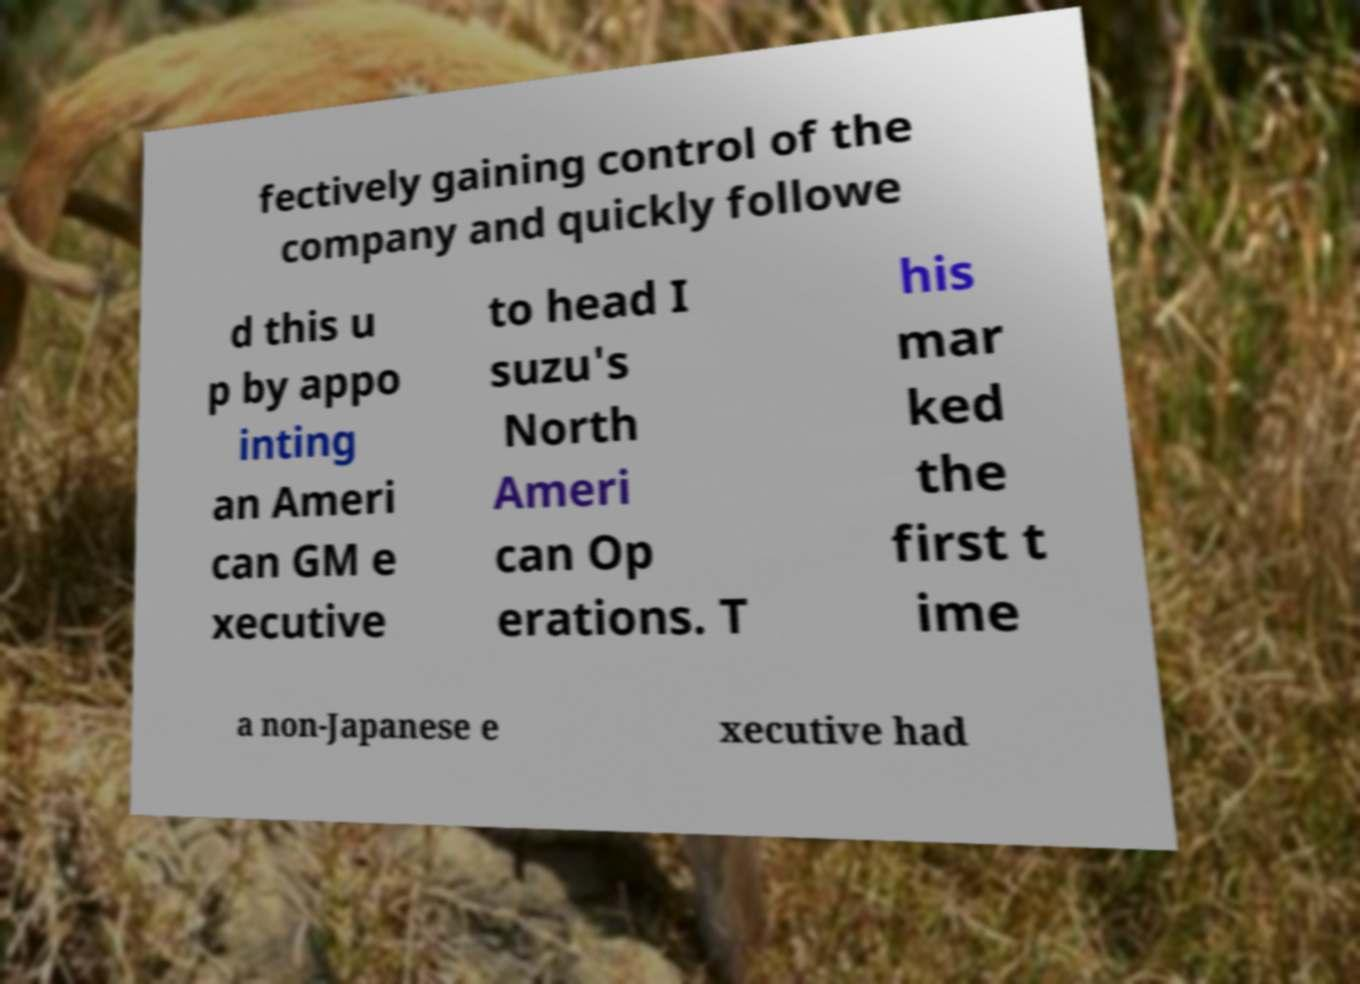Can you read and provide the text displayed in the image?This photo seems to have some interesting text. Can you extract and type it out for me? fectively gaining control of the company and quickly followe d this u p by appo inting an Ameri can GM e xecutive to head I suzu's North Ameri can Op erations. T his mar ked the first t ime a non-Japanese e xecutive had 